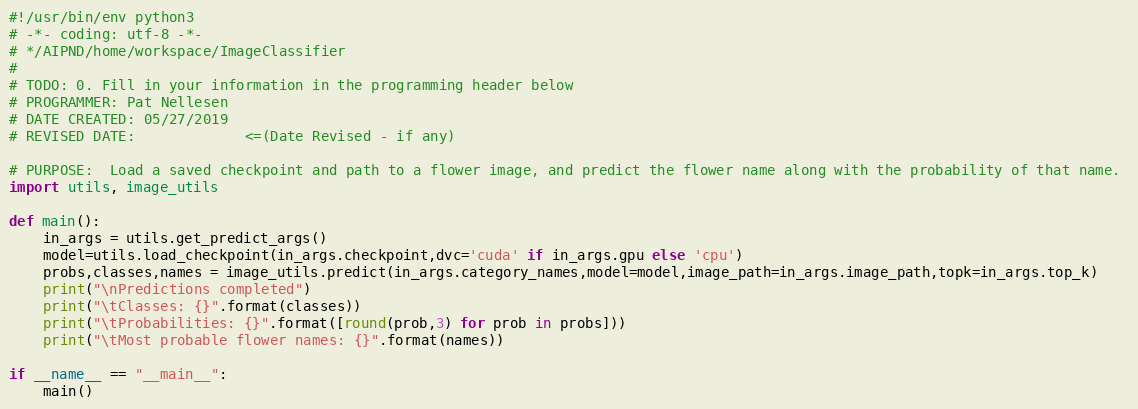<code> <loc_0><loc_0><loc_500><loc_500><_Python_>#!/usr/bin/env python3
# -*- coding: utf-8 -*-
# */AIPND/home/workspace/ImageClassifier
#                                                                             
# TODO: 0. Fill in your information in the programming header below
# PROGRAMMER: Pat Nellesen
# DATE CREATED: 05/27/2019
# REVISED DATE:             <=(Date Revised - if any)

# PURPOSE:  Load a saved checkpoint and path to a flower image, and predict the flower name along with the probability of that name. 
import utils, image_utils

def main():
    in_args = utils.get_predict_args()
    model=utils.load_checkpoint(in_args.checkpoint,dvc='cuda' if in_args.gpu else 'cpu')
    probs,classes,names = image_utils.predict(in_args.category_names,model=model,image_path=in_args.image_path,topk=in_args.top_k)
    print("\nPredictions completed")
    print("\tClasses: {}".format(classes))
    print("\tProbabilities: {}".format([round(prob,3) for prob in probs]))
    print("\tMost probable flower names: {}".format(names))
    
if __name__ == "__main__":
    main()      
</code> 